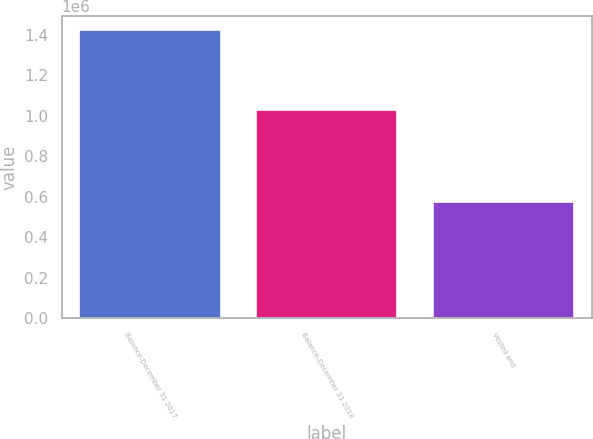Convert chart. <chart><loc_0><loc_0><loc_500><loc_500><bar_chart><fcel>Balance-December 31 2017<fcel>Balance-December 31 2018<fcel>Vested and<nl><fcel>1.42264e+06<fcel>1.02774e+06<fcel>574392<nl></chart> 